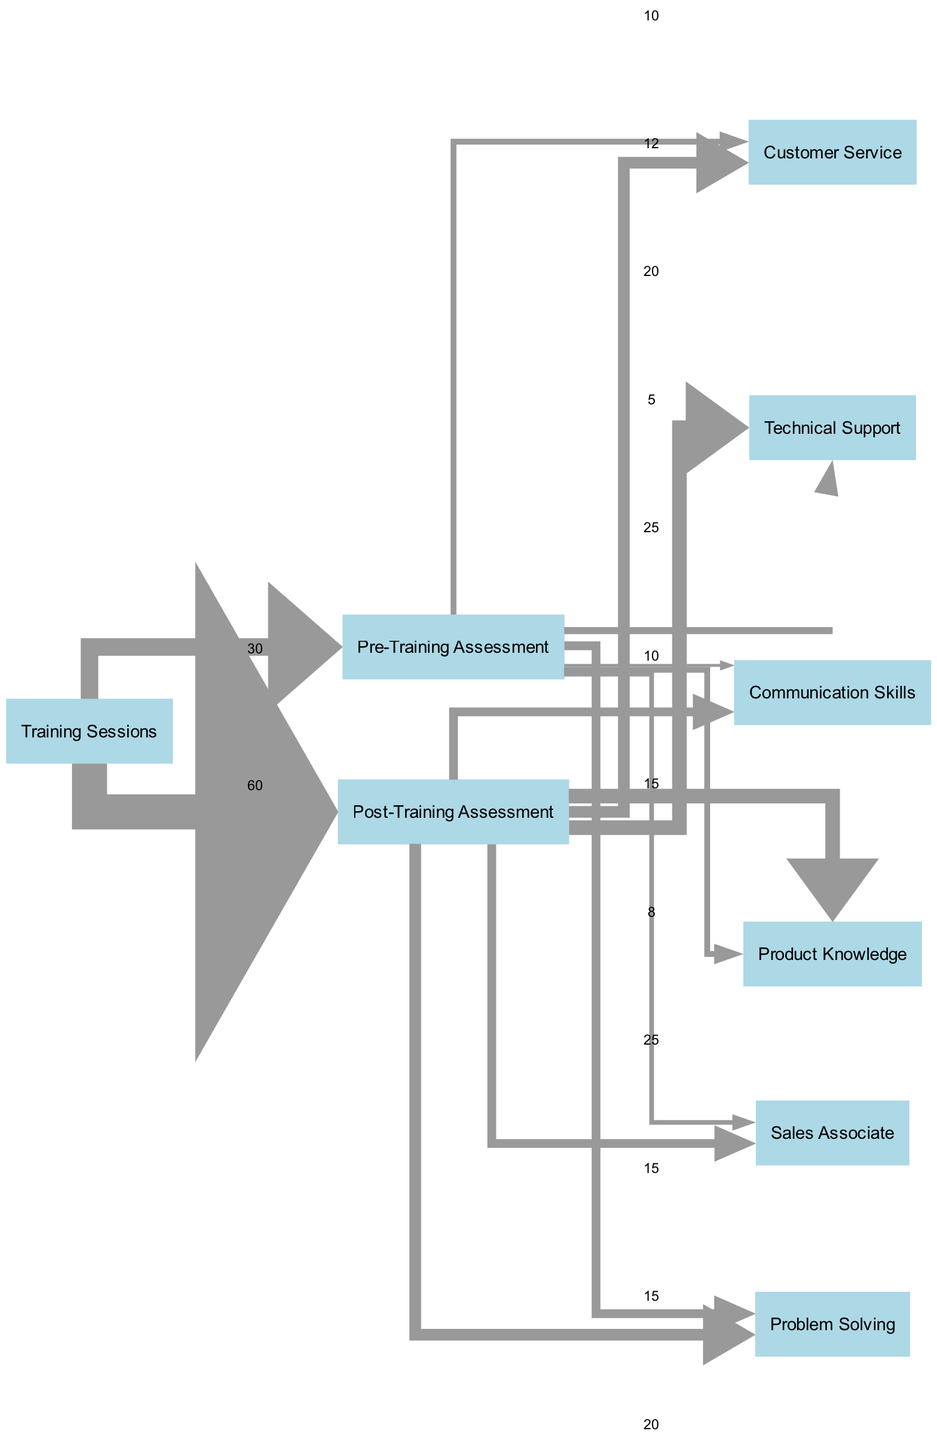What is the total number of nodes in the diagram? There are 8 distinct nodes listed in the data: "Training Sessions," "Customer Service," "Sales Associate," "Technical Support," "Pre-Training Assessment," "Post-Training Assessment," "Communication Skills," "Product Knowledge," and "Problem Solving." Therefore, the total is 8.
Answer: 8 What is the number of edges leading from the "Pre-Training Assessment" node? The "Pre-Training Assessment" node has 5 edges leading to "Customer Service," "Sales Associate," "Technical Support," "Communication Skills," and "Product Knowledge." Counting these edges gives a total of 5.
Answer: 5 Which skill had the highest post-training value? Looking at the "Post-Training Assessment" links, the skill with the highest value is "Product Knowledge," with a value of 25.
Answer: Product Knowledge What is the total improvement in customer service skills after training? The "Customer Service" skill had a pre-training assessment value of 10 and a post-training assessment value of 20. The improvement is calculated as 20 - 10 = 10.
Answer: 10 What percentage of the "Training Sessions" resulted in a positive change for "Technical Support"? The "Technical Support" role showed an increase from 12 in the pre-training assessment to 25 in the post-training assessment, indicating a change of 25 - 12 = 13. The percentage increase is calculated as (13 / 12) * 100 = 108.33%.
Answer: 108.33% Which skill improved the most from pre-training to post-training? Evaluating the changes: "Communication Skills" +10 (5 to 15), "Product Knowledge" +15 (10 to 25), "Problem Solving" +5 (15 to 20). The skill with the highest improvement is "Product Knowledge" with a change of +15.
Answer: Product Knowledge What is the total number of training sessions recorded? The diagram indicates that there are 30 participants who underwent training sessions, as verified by the link from "Training Sessions" to "Pre-Training Assessment."
Answer: 30 How many staff roles had a decrease in skills after training? There are no roles with decreased values from pre-training to post-training assessments; all roles show improvements in assessment scores.
Answer: 0 